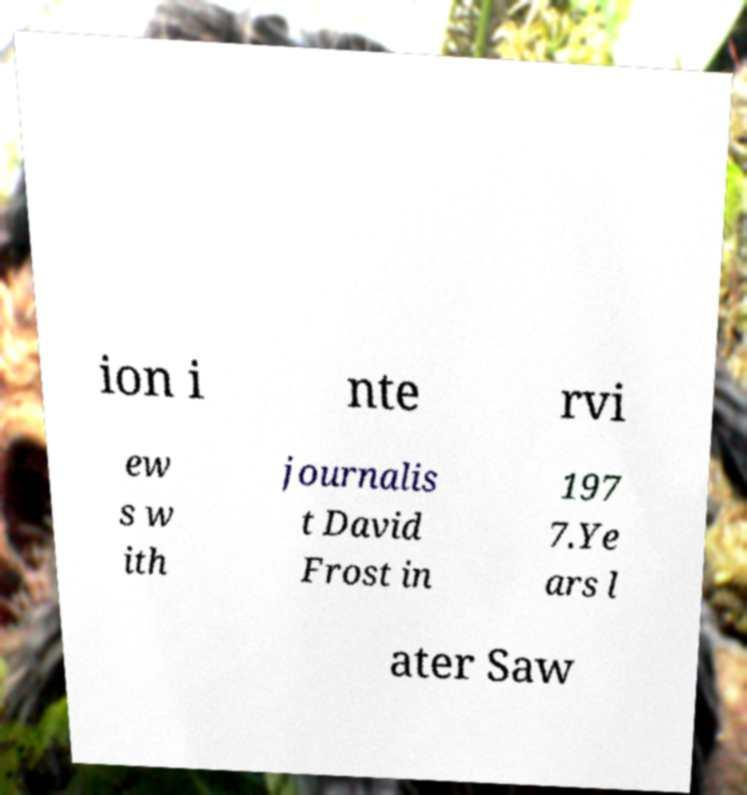Can you read and provide the text displayed in the image?This photo seems to have some interesting text. Can you extract and type it out for me? ion i nte rvi ew s w ith journalis t David Frost in 197 7.Ye ars l ater Saw 